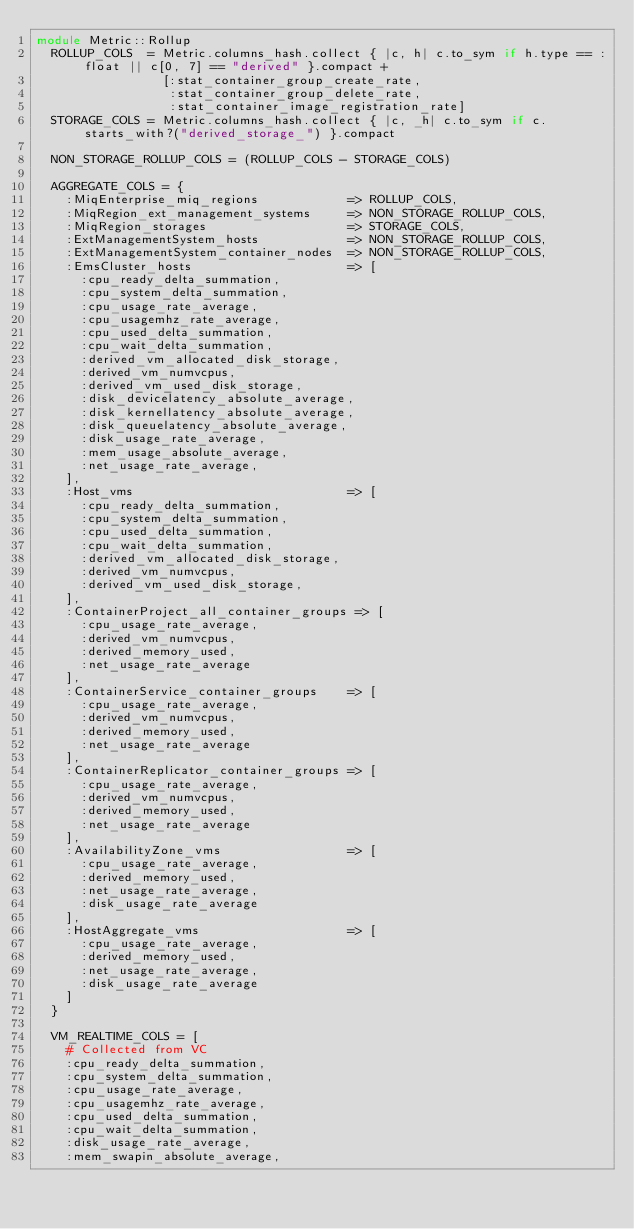Convert code to text. <code><loc_0><loc_0><loc_500><loc_500><_Ruby_>module Metric::Rollup
  ROLLUP_COLS  = Metric.columns_hash.collect { |c, h| c.to_sym if h.type == :float || c[0, 7] == "derived" }.compact +
                 [:stat_container_group_create_rate,
                  :stat_container_group_delete_rate,
                  :stat_container_image_registration_rate]
  STORAGE_COLS = Metric.columns_hash.collect { |c, _h| c.to_sym if c.starts_with?("derived_storage_") }.compact

  NON_STORAGE_ROLLUP_COLS = (ROLLUP_COLS - STORAGE_COLS)

  AGGREGATE_COLS = {
    :MiqEnterprise_miq_regions            => ROLLUP_COLS,
    :MiqRegion_ext_management_systems     => NON_STORAGE_ROLLUP_COLS,
    :MiqRegion_storages                   => STORAGE_COLS,
    :ExtManagementSystem_hosts            => NON_STORAGE_ROLLUP_COLS,
    :ExtManagementSystem_container_nodes  => NON_STORAGE_ROLLUP_COLS,
    :EmsCluster_hosts                     => [
      :cpu_ready_delta_summation,
      :cpu_system_delta_summation,
      :cpu_usage_rate_average,
      :cpu_usagemhz_rate_average,
      :cpu_used_delta_summation,
      :cpu_wait_delta_summation,
      :derived_vm_allocated_disk_storage,
      :derived_vm_numvcpus,
      :derived_vm_used_disk_storage,
      :disk_devicelatency_absolute_average,
      :disk_kernellatency_absolute_average,
      :disk_queuelatency_absolute_average,
      :disk_usage_rate_average,
      :mem_usage_absolute_average,
      :net_usage_rate_average,
    ],
    :Host_vms                             => [
      :cpu_ready_delta_summation,
      :cpu_system_delta_summation,
      :cpu_used_delta_summation,
      :cpu_wait_delta_summation,
      :derived_vm_allocated_disk_storage,
      :derived_vm_numvcpus,
      :derived_vm_used_disk_storage,
    ],
    :ContainerProject_all_container_groups => [
      :cpu_usage_rate_average,
      :derived_vm_numvcpus,
      :derived_memory_used,
      :net_usage_rate_average
    ],
    :ContainerService_container_groups    => [
      :cpu_usage_rate_average,
      :derived_vm_numvcpus,
      :derived_memory_used,
      :net_usage_rate_average
    ],
    :ContainerReplicator_container_groups => [
      :cpu_usage_rate_average,
      :derived_vm_numvcpus,
      :derived_memory_used,
      :net_usage_rate_average
    ],
    :AvailabilityZone_vms                 => [
      :cpu_usage_rate_average,
      :derived_memory_used,
      :net_usage_rate_average,
      :disk_usage_rate_average
    ],
    :HostAggregate_vms                    => [
      :cpu_usage_rate_average,
      :derived_memory_used,
      :net_usage_rate_average,
      :disk_usage_rate_average
    ]
  }

  VM_REALTIME_COLS = [
    # Collected from VC
    :cpu_ready_delta_summation,
    :cpu_system_delta_summation,
    :cpu_usage_rate_average,
    :cpu_usagemhz_rate_average,
    :cpu_used_delta_summation,
    :cpu_wait_delta_summation,
    :disk_usage_rate_average,
    :mem_swapin_absolute_average,</code> 